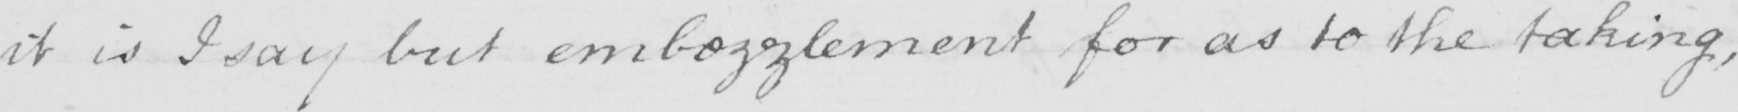What is written in this line of handwriting? it is I say but embezzlement for as to the taking , 